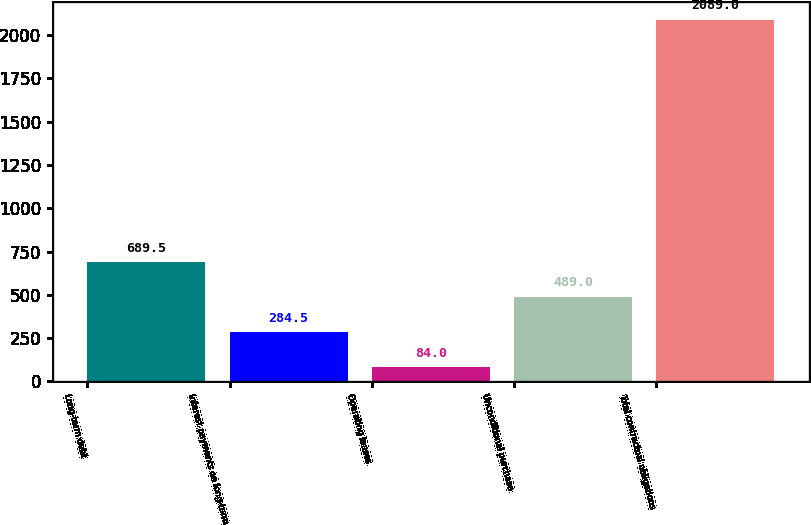<chart> <loc_0><loc_0><loc_500><loc_500><bar_chart><fcel>Long-term debt<fcel>Interest payments on long-term<fcel>Operating leases<fcel>Unconditional purchase<fcel>Total contractual obligations<nl><fcel>689.5<fcel>284.5<fcel>84<fcel>489<fcel>2089<nl></chart> 